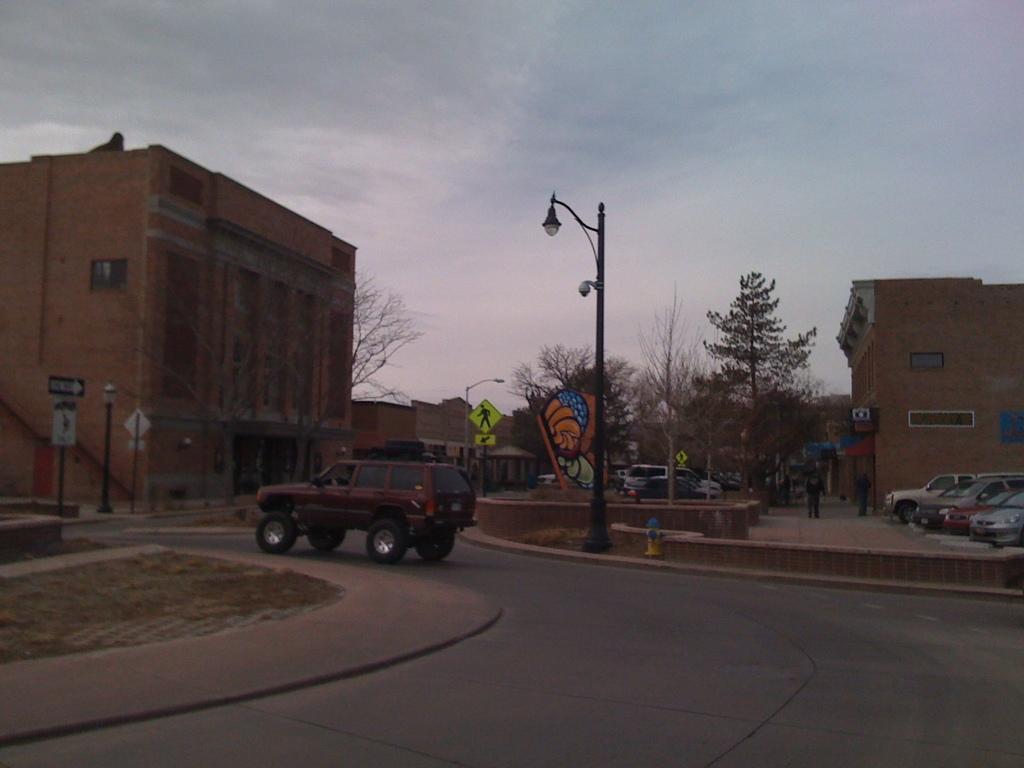Please provide a concise description of this image. In this picture we see buildings,parked vehicles and cloudy sky and a street pole light and a car moving on the road and few trees around. 